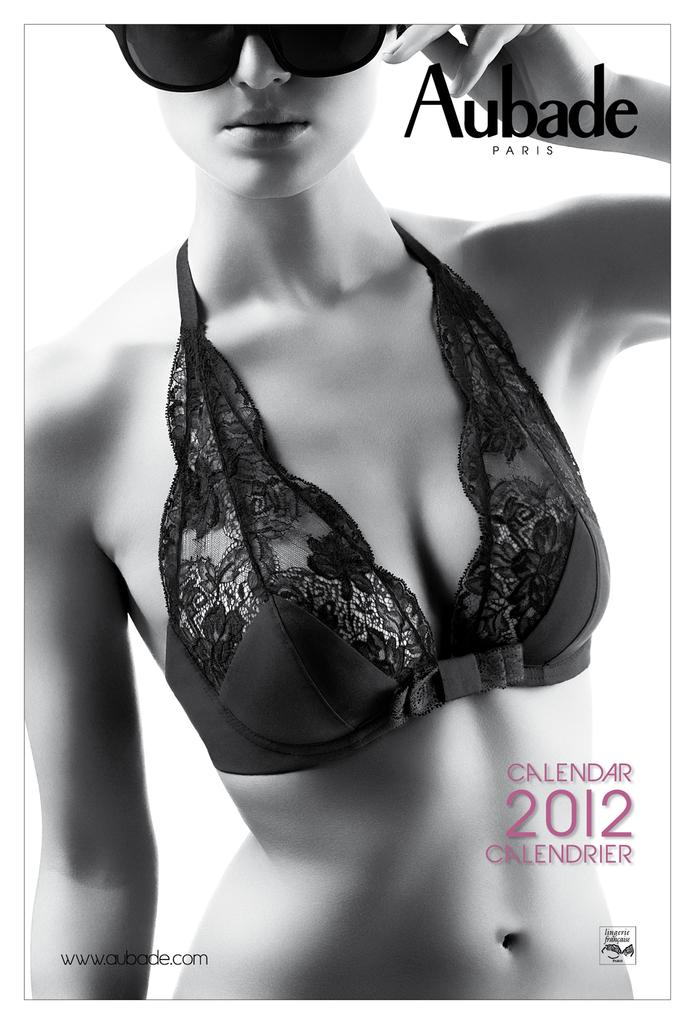Who is the main subject in the image? There is a girl in the image. What is the girl wearing in the image? The girl is wearing a bikini and black color spectacles. What is the color scheme of the image? The image is in black and white. What type of pencil can be seen in the girl's hand in the image? There is no pencil visible in the girl's hand in the image. Where can we find a cup in the image? There is no cup present in the image. 